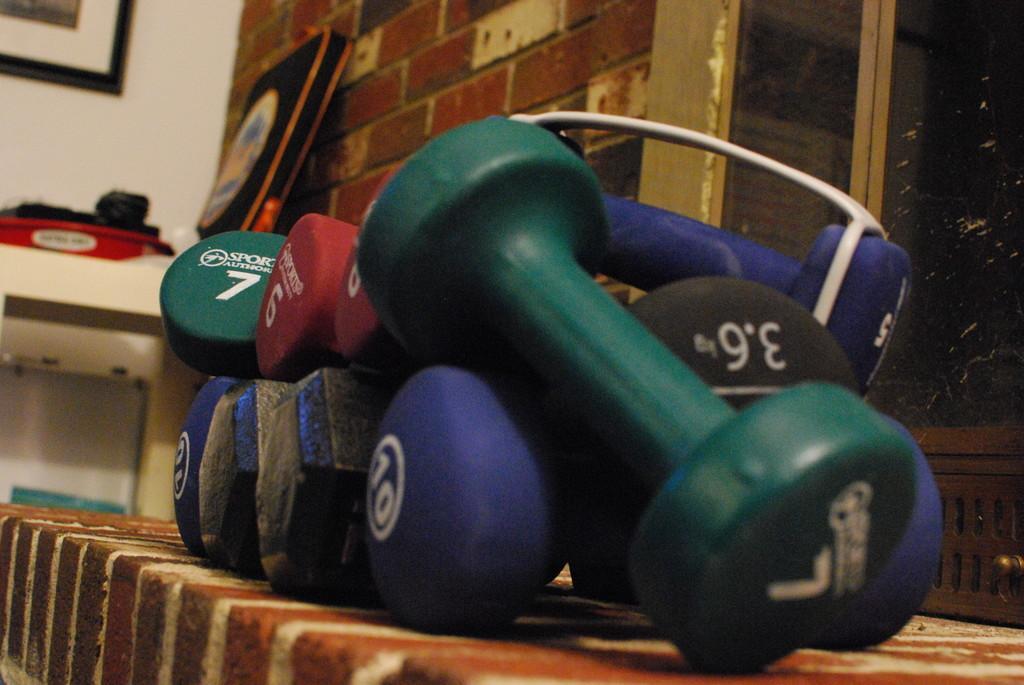Please provide a concise description of this image. This picture contains dumbbells which are in blue, green and red color. These dumbbells are placed on the table which is covered with brown color cloth. Behind that, we see a white table on which black bag and red box are placed. Beside that, we see a wall which is made up of bricks and we even see a window. In the background, we see a white wall on which photo frame is placed. 